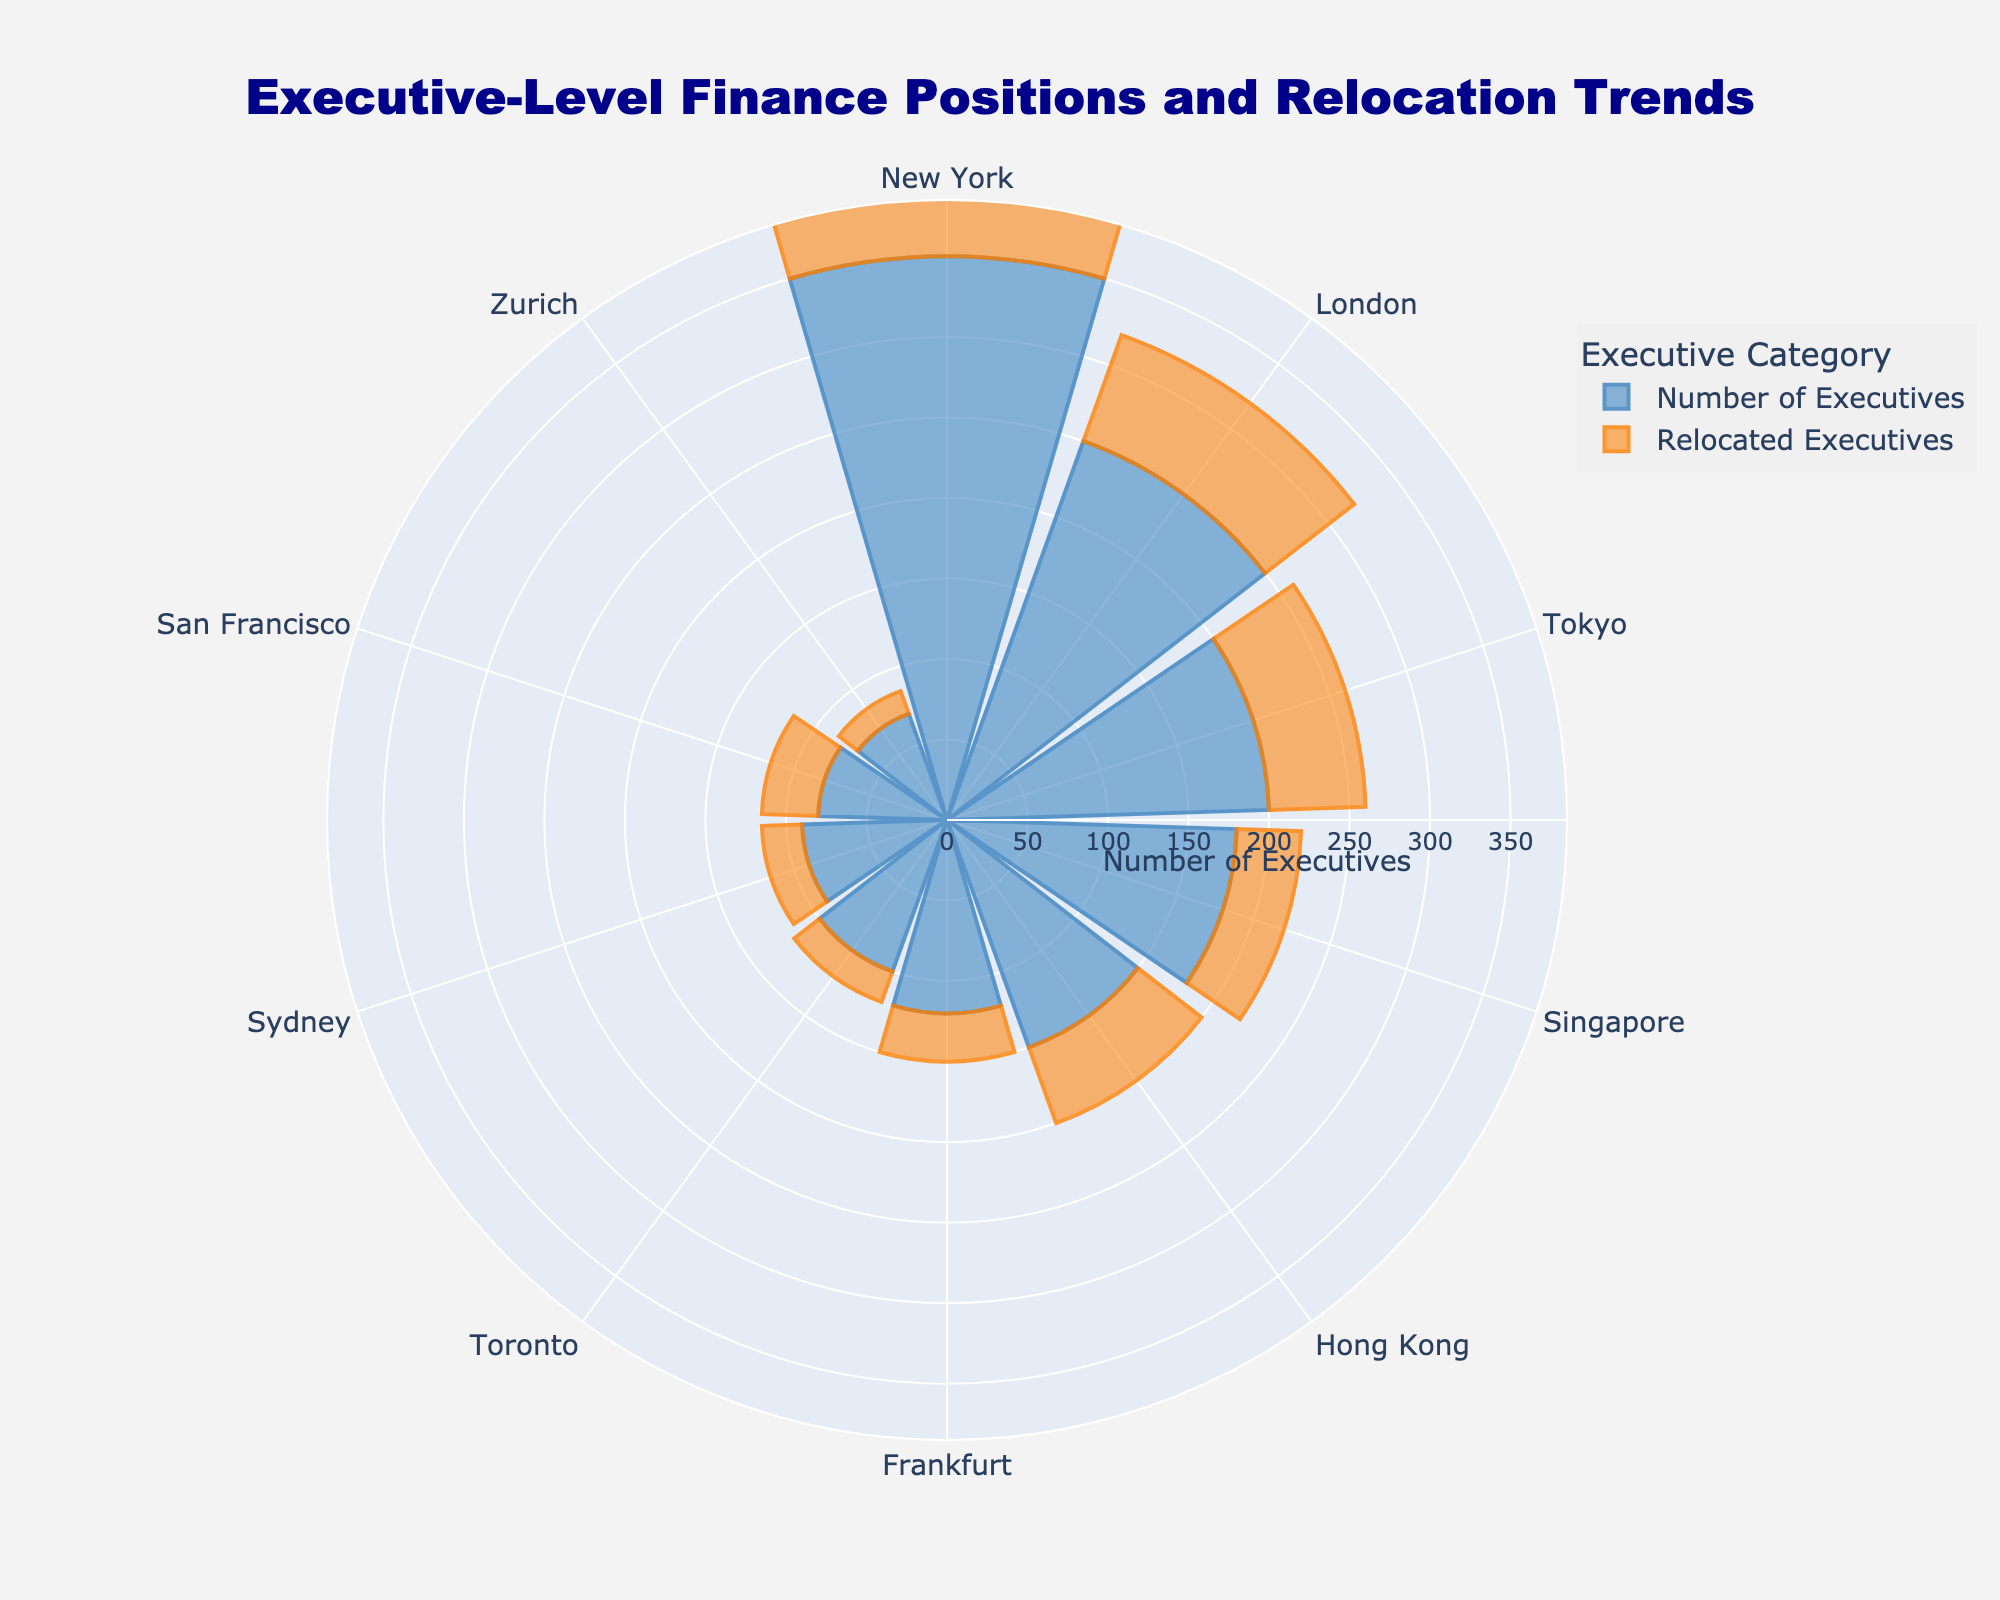What is the title of the polar area chart? The title is located at the top of the figure and reads 'Executive-Level Finance Positions and Relocation Trends'.
Answer: 'Executive-Level Finance Positions and Relocation Trends' Which geographic area has the highest number of executives? To identify the geographic area with the highest number of executives, observe the largest bar length in the first trace. New York has the longest bar, indicating it has the highest number of executives.
Answer: New York How many executives have been relocated from Tokyo? Locate the segment labeled 'Tokyo' and look at the bar for 'Relocated Executives'. The value is 60.
Answer: 60 What is the median relocation distance for Sydney? Find the annotation near the 'Sydney' segment. The distance displayed is 210 miles.
Answer: 210 miles Which geographic area has the highest relocation rate? Calculate the relocation rate as 'Relocated Executives' divided by 'Number of Executives' for each segment. Compare the results; Tokyo has the highest rate (60/200 = 0.30).
Answer: Tokyo Compare the number of executives between London and Frankfurt. Which has more and by how much? Observe the 'Number of Executives' bars for London and Frankfurt. London has 250, and Frankfurt has 120. The difference is 250 - 120 = 130.
Answer: London by 130 What is the range of the radial axis in the chart? The radial axis range is indicated in the plot settings and it starts at 0, going up to slightly more than the highest 'Number of Executives' value of 350. The range is from 0 to approximately 385.
Answer: 0 to 385 How many areas have more than 100 relocated executives? Number of areas with over 100 executives is derived by observing all segments; none of the bars reach 100 for 'Relocated Executives'.
Answer: 0 Which geographic area has the longest annotated text about relocation? By inspecting the annotations around the plot, the longest annotation has the most relocation info. Singapore has a text reading "Rate: 22%<br>Dist: 250 mi", spanning two lines.
Answer: Singapore Between Zurich and San Francisco, which one has a higher relocation distance and by how much? Reviewing the annotations for 'Median Relocation Distance', Zurich shows 230 miles, while San Francisco shows 160 miles. The difference is 230 - 160 = 70 miles.
Answer: Zurich by 70 miles 